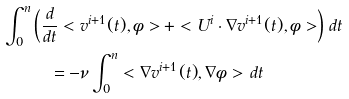<formula> <loc_0><loc_0><loc_500><loc_500>\int _ { 0 } ^ { n } & \left ( \frac { d } { d t } < v ^ { i + 1 } ( t ) , \phi > + < U ^ { i } \cdot \nabla v ^ { i + 1 } ( t ) , \phi > \right ) \, d t \\ & \quad = - \nu \int _ { 0 } ^ { n } < \nabla v ^ { i + 1 } ( t ) , \nabla \phi > \, d t</formula> 